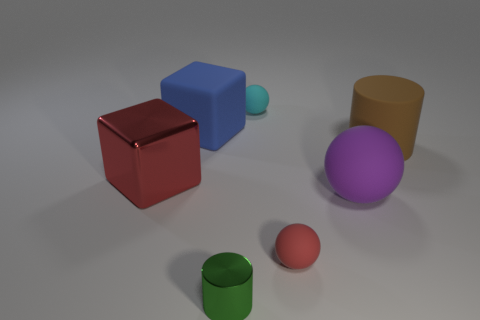Add 1 cyan cylinders. How many objects exist? 8 Subtract all balls. How many objects are left? 4 Subtract 0 red cylinders. How many objects are left? 7 Subtract all large shiny blocks. Subtract all large brown rubber cylinders. How many objects are left? 5 Add 4 big purple rubber objects. How many big purple rubber objects are left? 5 Add 3 small red metal things. How many small red metal things exist? 3 